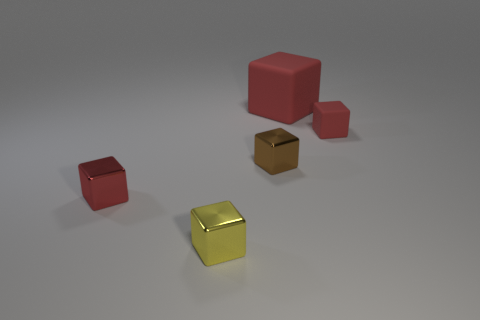How many big red matte objects are behind the small yellow metal cube?
Offer a very short reply. 1. What number of other things are there of the same shape as the yellow shiny thing?
Give a very brief answer. 4. Are there fewer large matte things than red objects?
Your answer should be very brief. Yes. There is a shiny object that is both to the left of the tiny brown thing and behind the yellow cube; what size is it?
Your response must be concise. Small. How big is the metallic block behind the red thing in front of the metallic object that is right of the tiny yellow metal cube?
Keep it short and to the point. Small. The yellow metal cube has what size?
Provide a short and direct response. Small. Is there anything else that is made of the same material as the brown thing?
Ensure brevity in your answer.  Yes. There is a red rubber cube that is behind the small red thing to the right of the tiny brown thing; is there a brown metal thing behind it?
Your answer should be compact. No. How many tiny objects are either metal objects or yellow metallic objects?
Offer a terse response. 3. Is there any other thing of the same color as the big matte thing?
Provide a short and direct response. Yes. 